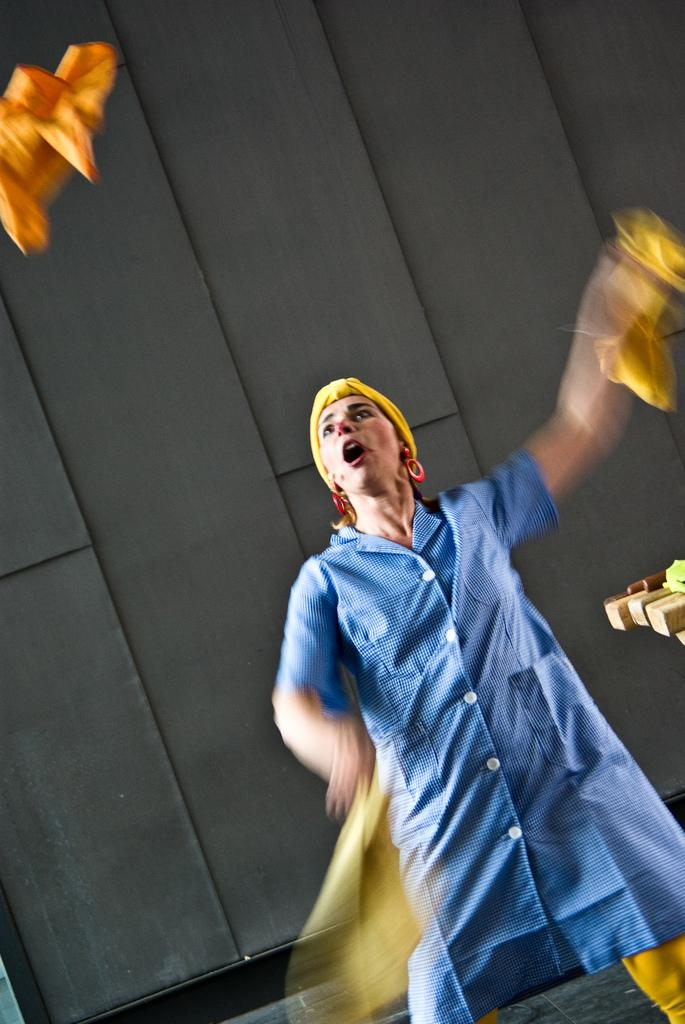Who is the main subject in the image? There is a lady in the center of the image. What can be seen in the background of the image? There is black color cloth in the background of the image. What type of songs can be heard coming from the harbor in the image? There is no harbor present in the image, so it's not possible to determine what, if any, songs might be heard. 